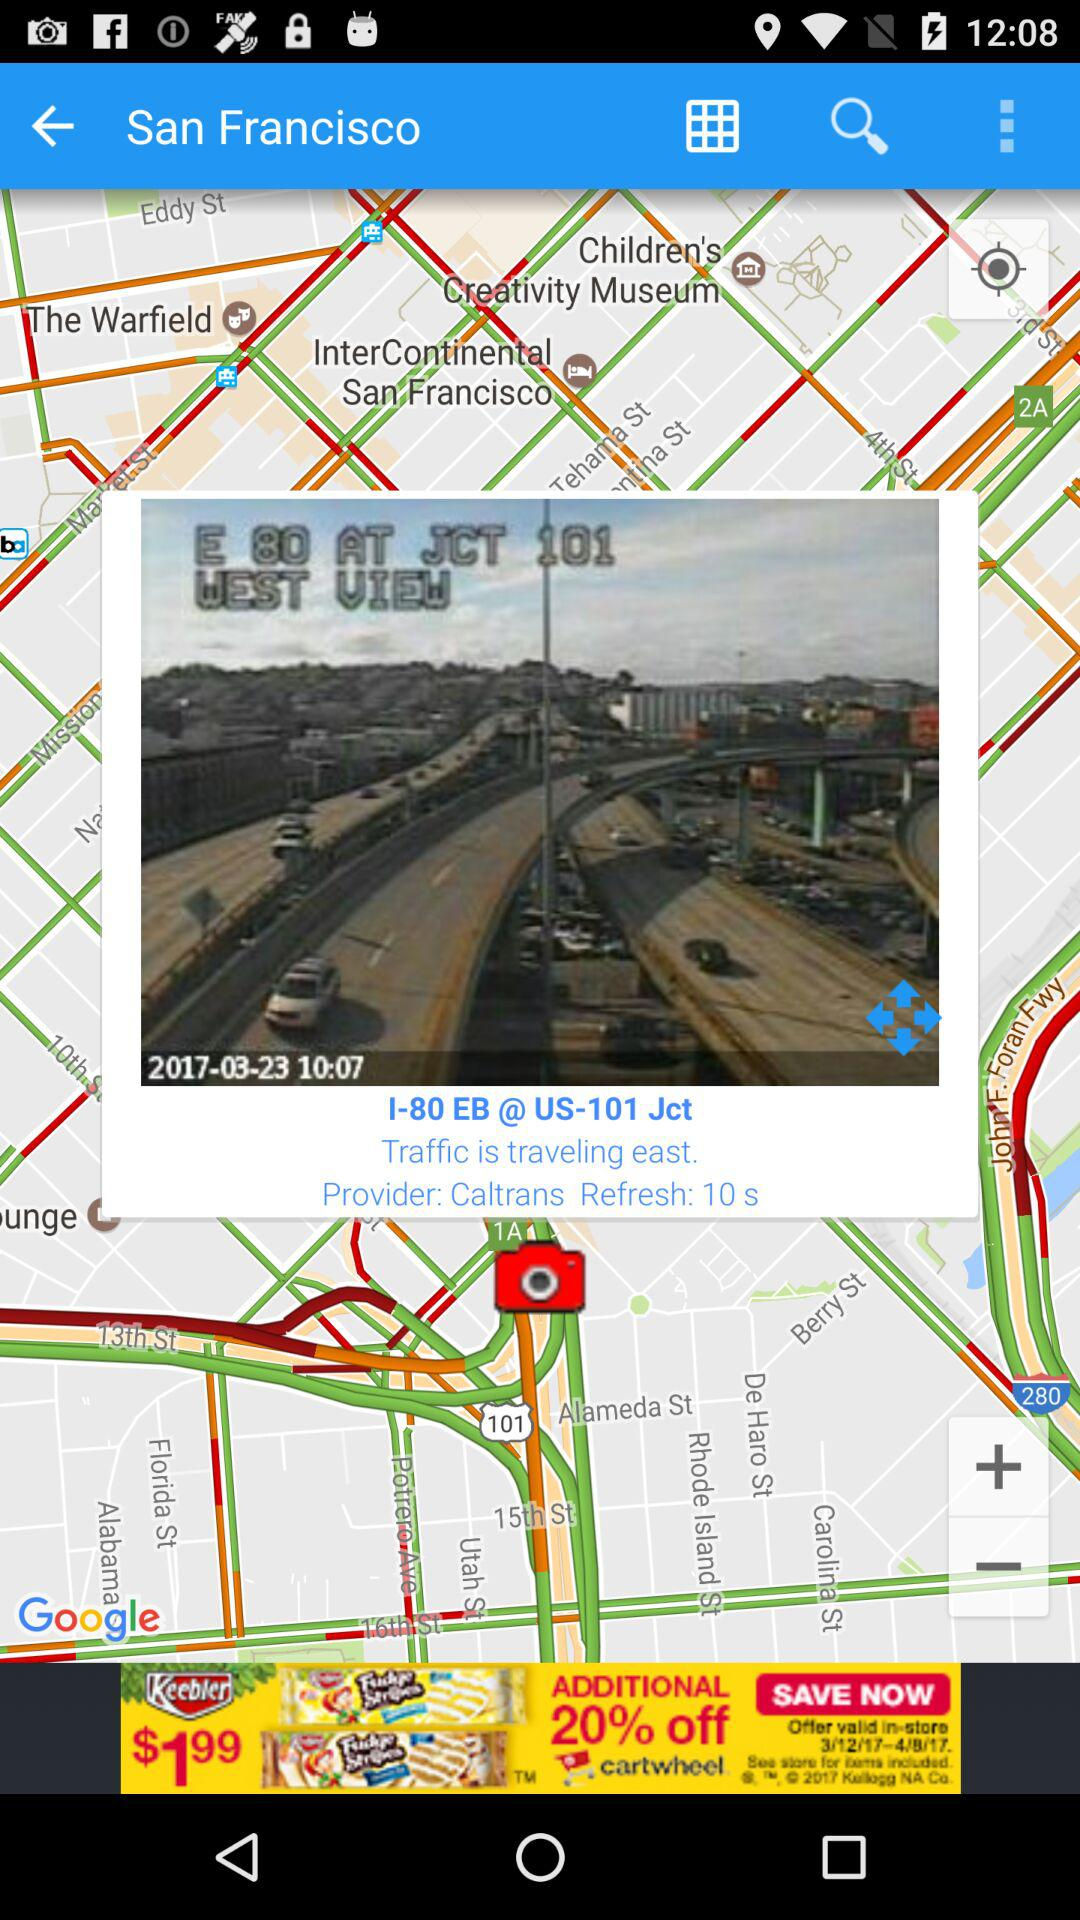What is the current location? The current location is San Francisco. 